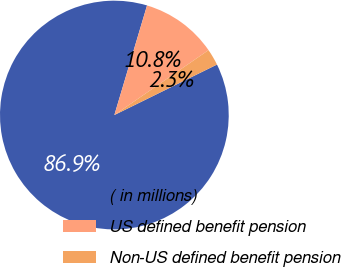Convert chart. <chart><loc_0><loc_0><loc_500><loc_500><pie_chart><fcel>( in millions)<fcel>US defined benefit pension<fcel>Non-US defined benefit pension<nl><fcel>86.89%<fcel>10.78%<fcel>2.33%<nl></chart> 